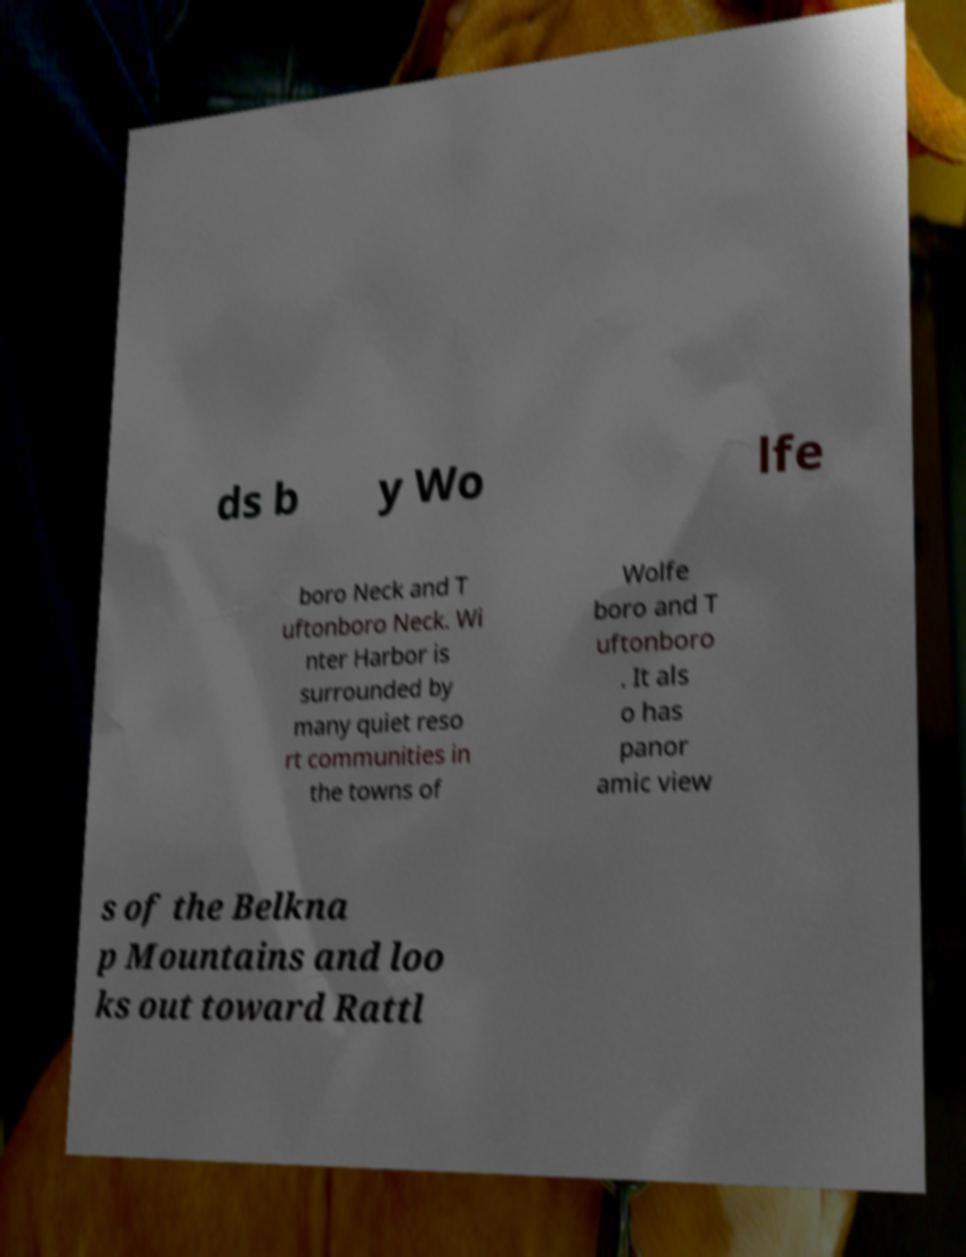What messages or text are displayed in this image? I need them in a readable, typed format. ds b y Wo lfe boro Neck and T uftonboro Neck. Wi nter Harbor is surrounded by many quiet reso rt communities in the towns of Wolfe boro and T uftonboro . It als o has panor amic view s of the Belkna p Mountains and loo ks out toward Rattl 